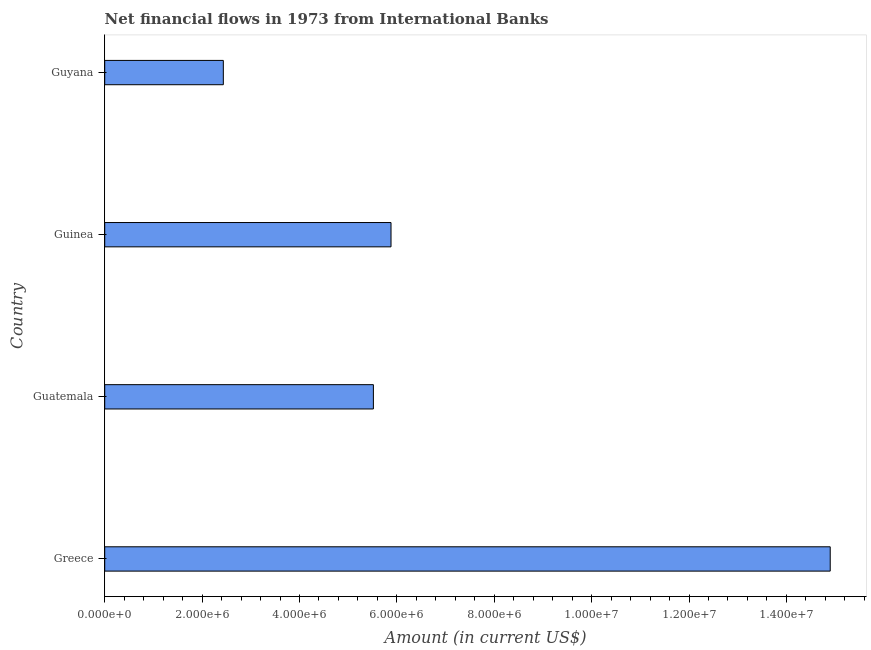Does the graph contain any zero values?
Make the answer very short. No. What is the title of the graph?
Keep it short and to the point. Net financial flows in 1973 from International Banks. What is the label or title of the Y-axis?
Provide a succinct answer. Country. What is the net financial flows from ibrd in Guinea?
Offer a very short reply. 5.88e+06. Across all countries, what is the maximum net financial flows from ibrd?
Keep it short and to the point. 1.49e+07. Across all countries, what is the minimum net financial flows from ibrd?
Make the answer very short. 2.44e+06. In which country was the net financial flows from ibrd maximum?
Keep it short and to the point. Greece. In which country was the net financial flows from ibrd minimum?
Your answer should be compact. Guyana. What is the sum of the net financial flows from ibrd?
Keep it short and to the point. 2.87e+07. What is the difference between the net financial flows from ibrd in Guatemala and Guinea?
Ensure brevity in your answer.  -3.62e+05. What is the average net financial flows from ibrd per country?
Offer a very short reply. 7.18e+06. What is the median net financial flows from ibrd?
Offer a very short reply. 5.70e+06. What is the ratio of the net financial flows from ibrd in Greece to that in Guyana?
Your answer should be very brief. 6.12. Is the difference between the net financial flows from ibrd in Guinea and Guyana greater than the difference between any two countries?
Your response must be concise. No. What is the difference between the highest and the second highest net financial flows from ibrd?
Provide a short and direct response. 9.02e+06. Is the sum of the net financial flows from ibrd in Greece and Guinea greater than the maximum net financial flows from ibrd across all countries?
Your answer should be very brief. Yes. What is the difference between the highest and the lowest net financial flows from ibrd?
Ensure brevity in your answer.  1.25e+07. How many bars are there?
Keep it short and to the point. 4. Are all the bars in the graph horizontal?
Offer a very short reply. Yes. How many countries are there in the graph?
Provide a short and direct response. 4. What is the difference between two consecutive major ticks on the X-axis?
Keep it short and to the point. 2.00e+06. Are the values on the major ticks of X-axis written in scientific E-notation?
Your response must be concise. Yes. What is the Amount (in current US$) in Greece?
Provide a succinct answer. 1.49e+07. What is the Amount (in current US$) in Guatemala?
Your response must be concise. 5.52e+06. What is the Amount (in current US$) of Guinea?
Keep it short and to the point. 5.88e+06. What is the Amount (in current US$) of Guyana?
Offer a very short reply. 2.44e+06. What is the difference between the Amount (in current US$) in Greece and Guatemala?
Offer a very short reply. 9.38e+06. What is the difference between the Amount (in current US$) in Greece and Guinea?
Offer a terse response. 9.02e+06. What is the difference between the Amount (in current US$) in Greece and Guyana?
Give a very brief answer. 1.25e+07. What is the difference between the Amount (in current US$) in Guatemala and Guinea?
Offer a very short reply. -3.62e+05. What is the difference between the Amount (in current US$) in Guatemala and Guyana?
Provide a succinct answer. 3.08e+06. What is the difference between the Amount (in current US$) in Guinea and Guyana?
Keep it short and to the point. 3.44e+06. What is the ratio of the Amount (in current US$) in Greece to that in Guatemala?
Provide a succinct answer. 2.7. What is the ratio of the Amount (in current US$) in Greece to that in Guinea?
Give a very brief answer. 2.53. What is the ratio of the Amount (in current US$) in Greece to that in Guyana?
Provide a succinct answer. 6.12. What is the ratio of the Amount (in current US$) in Guatemala to that in Guinea?
Offer a very short reply. 0.94. What is the ratio of the Amount (in current US$) in Guatemala to that in Guyana?
Your answer should be very brief. 2.27. What is the ratio of the Amount (in current US$) in Guinea to that in Guyana?
Offer a very short reply. 2.41. 